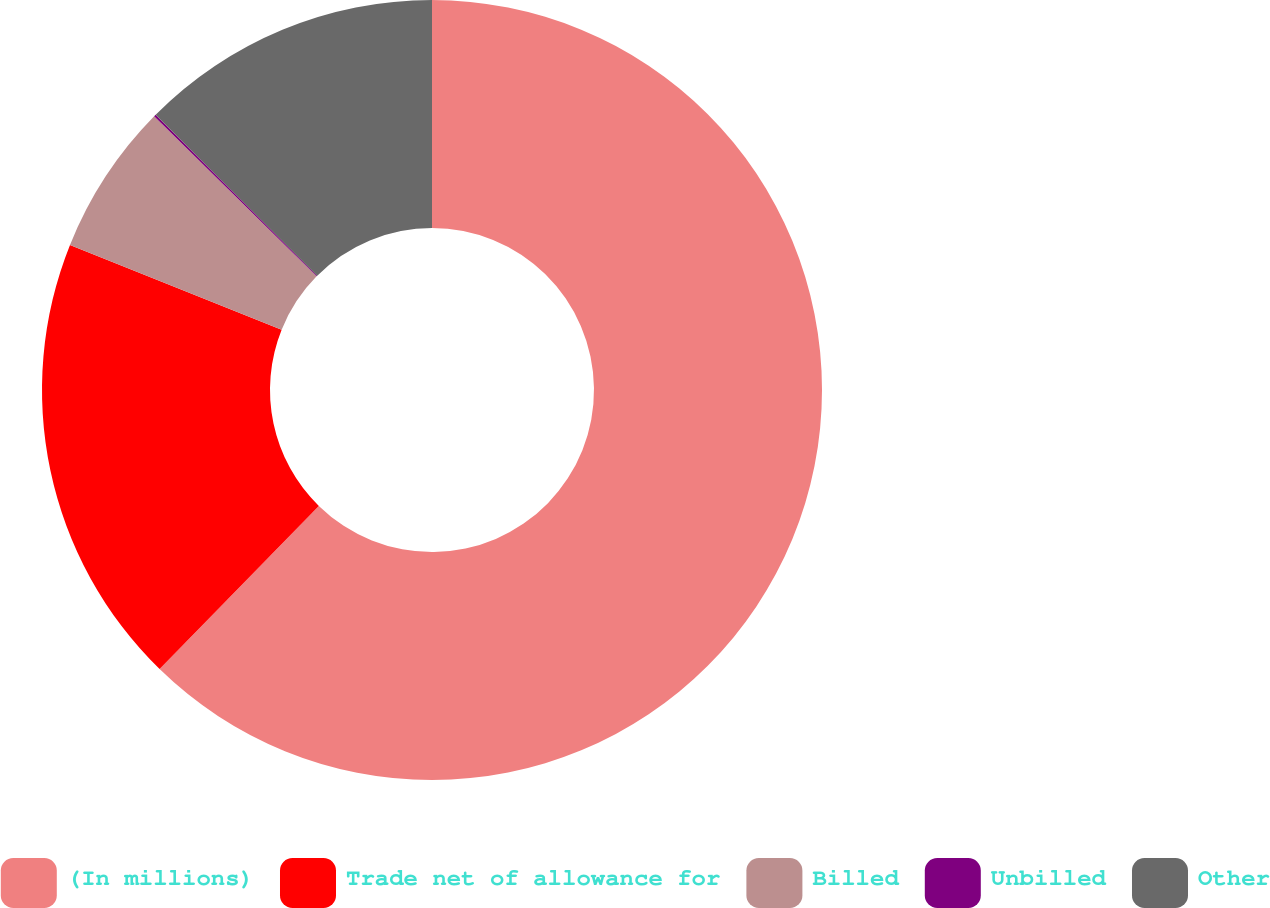<chart> <loc_0><loc_0><loc_500><loc_500><pie_chart><fcel>(In millions)<fcel>Trade net of allowance for<fcel>Billed<fcel>Unbilled<fcel>Other<nl><fcel>62.3%<fcel>18.76%<fcel>6.31%<fcel>0.09%<fcel>12.53%<nl></chart> 